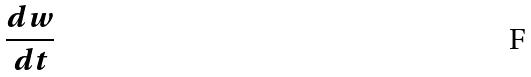<formula> <loc_0><loc_0><loc_500><loc_500>\frac { d w } { d t }</formula> 